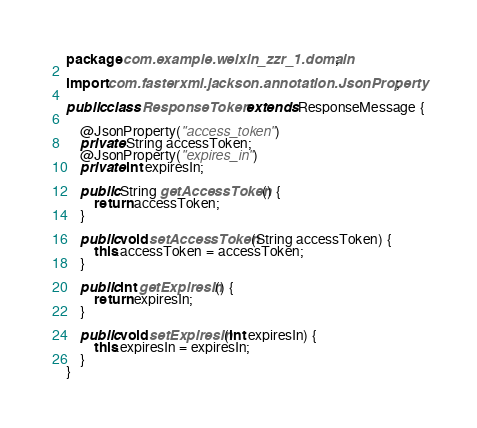Convert code to text. <code><loc_0><loc_0><loc_500><loc_500><_Java_>package com.example.weixin_zzr_1.domain;

import com.fasterxml.jackson.annotation.JsonProperty;

public class ResponseToken extends ResponseMessage {

	@JsonProperty("access_token")
	private String accessToken;
	@JsonProperty("expires_in")
	private int expiresIn;

	public String getAccessToken() {
		return accessToken;
	}

	public void setAccessToken(String accessToken) {
		this.accessToken = accessToken;
	}

	public int getExpiresIn() {
		return expiresIn;
	}

	public void setExpiresIn(int expiresIn) {
		this.expiresIn = expiresIn;
	}
}
</code> 